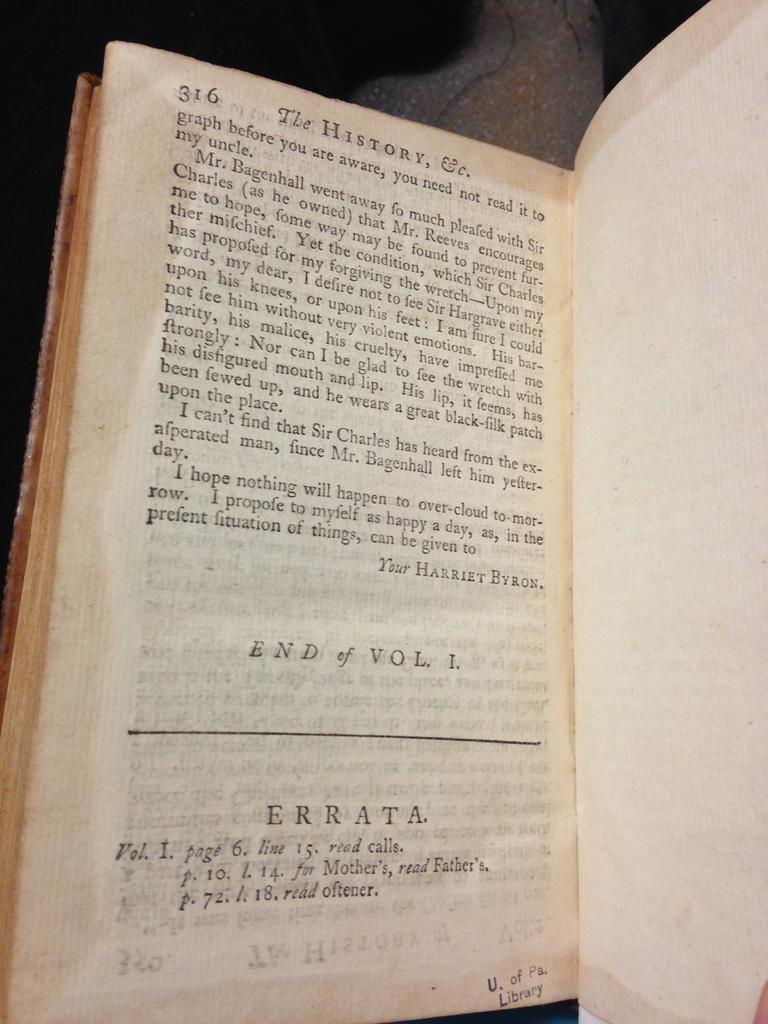<image>
Summarize the visual content of the image. A book titled "The history" page 316 the end of Volume one. 